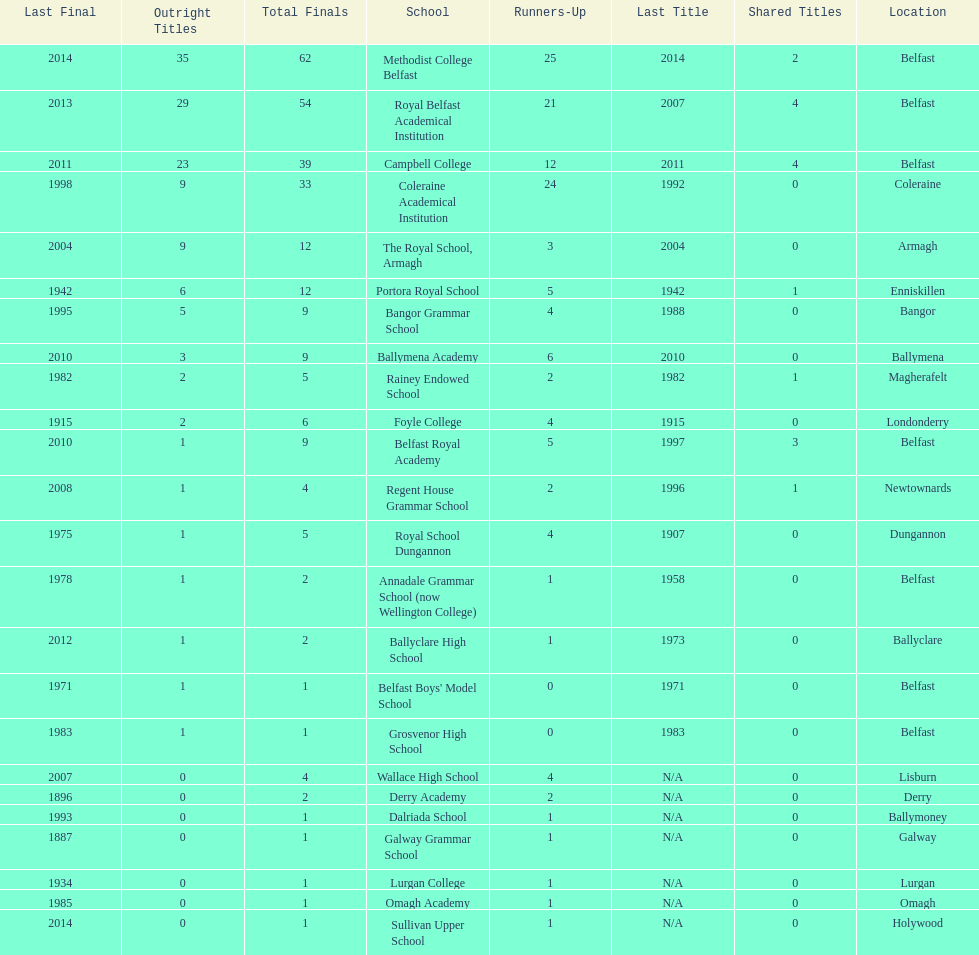How many schools had above 5 outright titles? 6. 